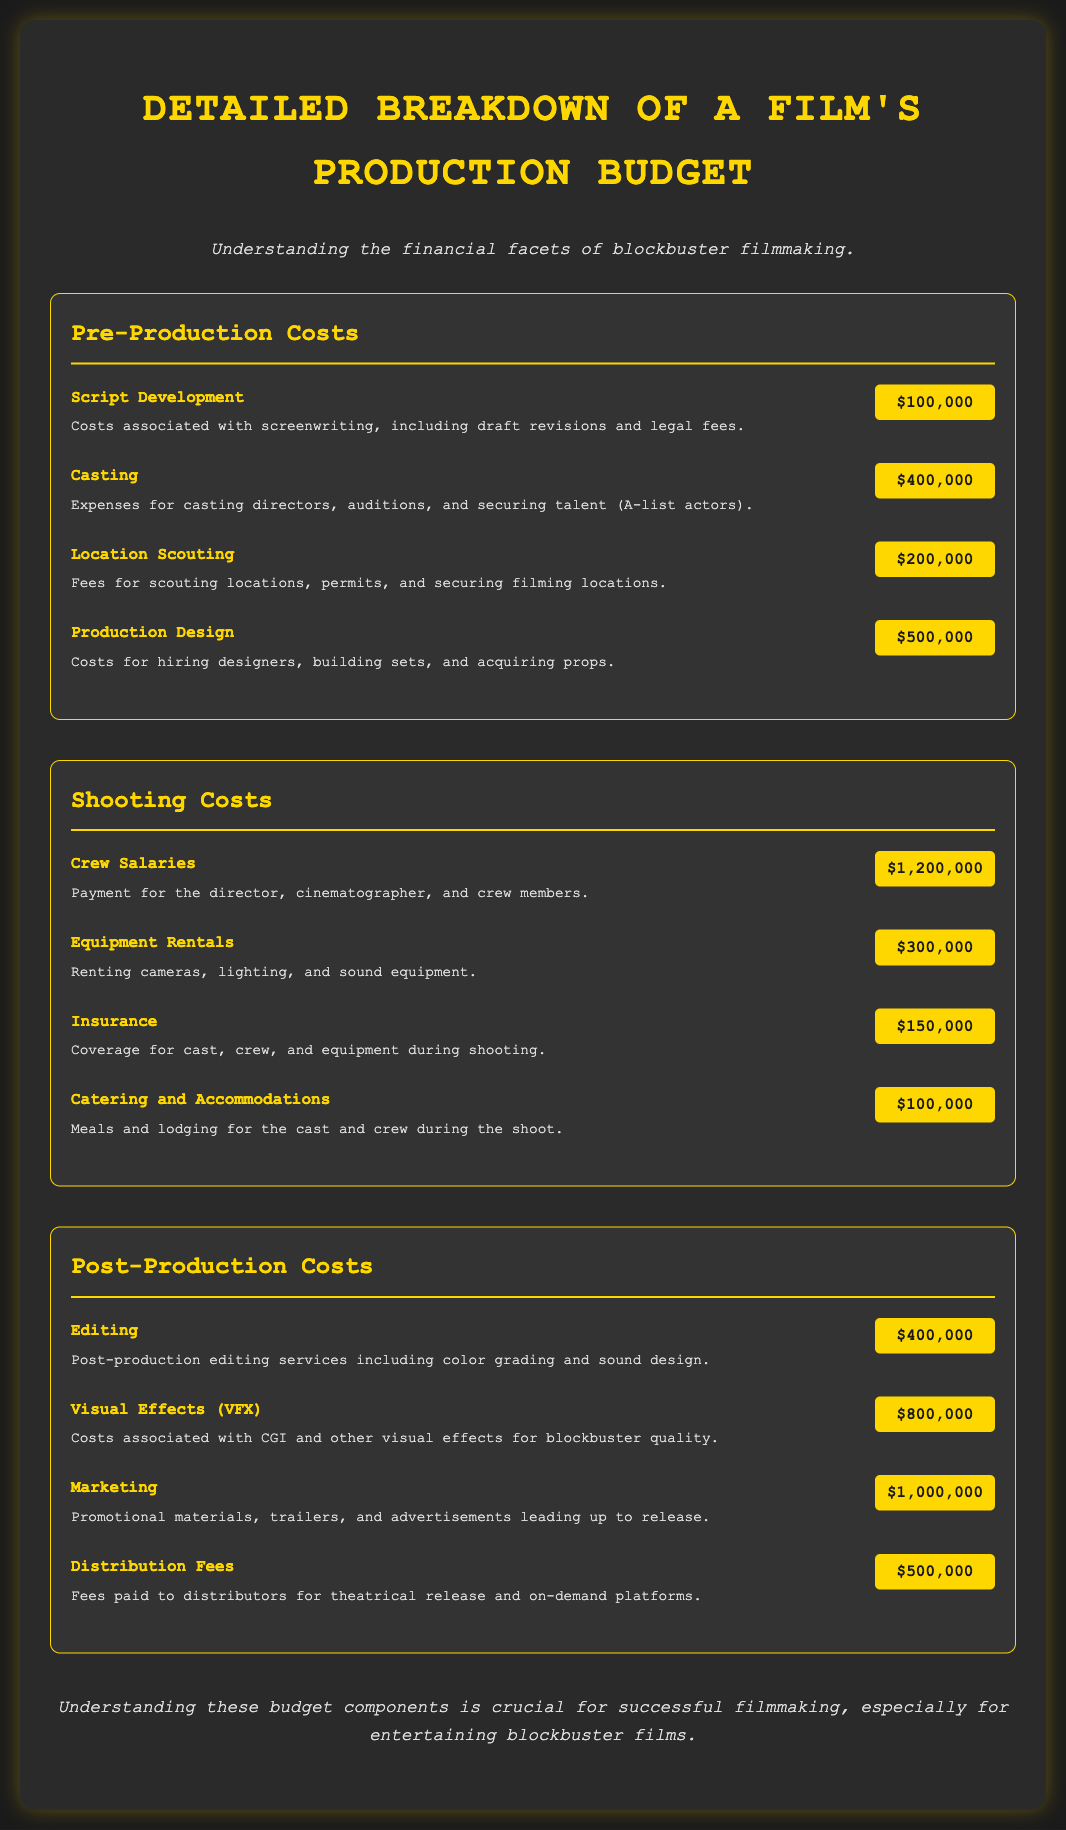What is the total cost for Script Development? The document states that the cost for Script Development is $100,000.
Answer: $100,000 What is the largest expenditure in Post-Production Costs? Visual Effects (VFX) costs $800,000, which is the highest among post-production items.
Answer: $800,000 What is the cost of Catering and Accommodations? The document lists Catering and Accommodations at $100,000.
Answer: $100,000 What percentage of the Shooting Costs is Crew Salaries? Crew Salaries total $1,200,000; the total Shooting Costs is $2,250,000 ($1,200,000 + $300,000 + $150,000 + $100,000), making Crew Salaries approximately 53.3% of Shooting Costs.
Answer: 53.3% How much are the total Pre-Production Costs? The total Pre-Production Costs is the sum of all pre-production items: $100,000 + $400,000 + $200,000 + $500,000 = $1,200,000.
Answer: $1,200,000 What is the main purpose of the Marketing cost? The document describes Marketing costs as pertaining to promotional materials, trailers, and advertisements leading up to release.
Answer: Promotional materials How much is spent on Equipment Rentals? The Equipment Rentals cost is clearly stated as $300,000 in the document.
Answer: $300,000 What is the total budget on Distribution Fees and Marketing combined? Combining Distribution Fees ($500,000) and Marketing ($1,000,000) gives a total of $1,500,000.
Answer: $1,500,000 How are the contributions of pre-production costs conveyed in the document? The document outlines specific pre-production expenses such as script development, casting, location scouting, and production design, reflecting their individual financial contributions.
Answer: Detailed breakdown 